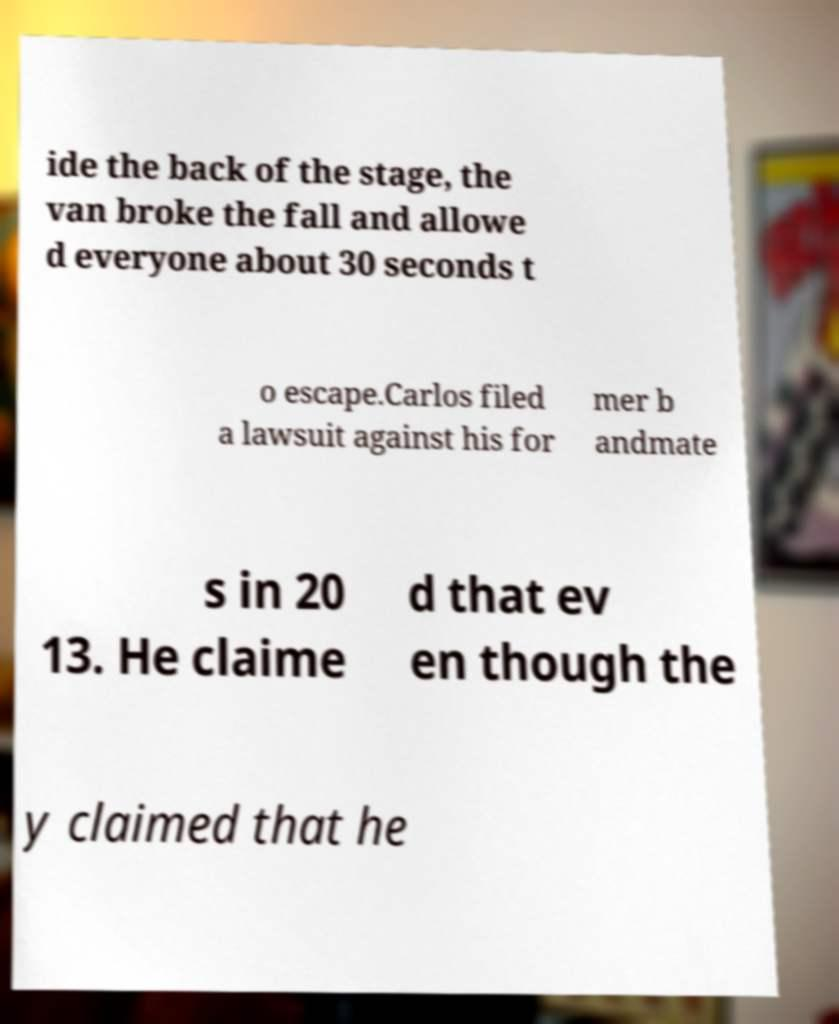Please read and relay the text visible in this image. What does it say? ide the back of the stage, the van broke the fall and allowe d everyone about 30 seconds t o escape.Carlos filed a lawsuit against his for mer b andmate s in 20 13. He claime d that ev en though the y claimed that he 